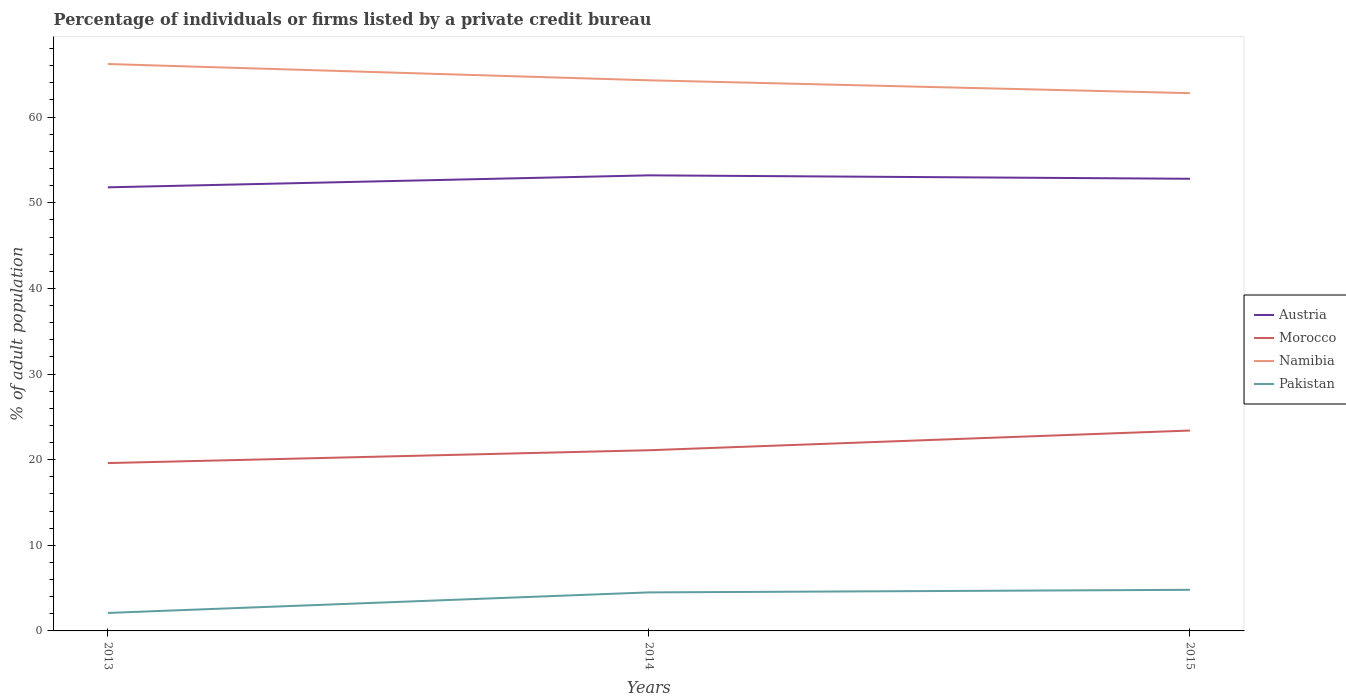How many different coloured lines are there?
Your answer should be very brief. 4. Does the line corresponding to Morocco intersect with the line corresponding to Austria?
Provide a short and direct response. No. Is the number of lines equal to the number of legend labels?
Offer a very short reply. Yes. Across all years, what is the maximum percentage of population listed by a private credit bureau in Namibia?
Offer a terse response. 62.8. In which year was the percentage of population listed by a private credit bureau in Namibia maximum?
Provide a short and direct response. 2015. What is the total percentage of population listed by a private credit bureau in Austria in the graph?
Give a very brief answer. -1.4. What is the difference between the highest and the second highest percentage of population listed by a private credit bureau in Austria?
Provide a succinct answer. 1.4. What is the difference between the highest and the lowest percentage of population listed by a private credit bureau in Austria?
Give a very brief answer. 2. How many years are there in the graph?
Provide a short and direct response. 3. Are the values on the major ticks of Y-axis written in scientific E-notation?
Give a very brief answer. No. Does the graph contain grids?
Your answer should be compact. No. Where does the legend appear in the graph?
Provide a succinct answer. Center right. How many legend labels are there?
Keep it short and to the point. 4. What is the title of the graph?
Ensure brevity in your answer.  Percentage of individuals or firms listed by a private credit bureau. Does "Timor-Leste" appear as one of the legend labels in the graph?
Your answer should be compact. No. What is the label or title of the X-axis?
Offer a very short reply. Years. What is the label or title of the Y-axis?
Your answer should be very brief. % of adult population. What is the % of adult population of Austria in 2013?
Your answer should be very brief. 51.8. What is the % of adult population in Morocco in 2013?
Ensure brevity in your answer.  19.6. What is the % of adult population of Namibia in 2013?
Your answer should be compact. 66.2. What is the % of adult population of Austria in 2014?
Make the answer very short. 53.2. What is the % of adult population of Morocco in 2014?
Your answer should be very brief. 21.1. What is the % of adult population in Namibia in 2014?
Offer a terse response. 64.3. What is the % of adult population in Austria in 2015?
Ensure brevity in your answer.  52.8. What is the % of adult population in Morocco in 2015?
Offer a very short reply. 23.4. What is the % of adult population in Namibia in 2015?
Offer a very short reply. 62.8. What is the % of adult population of Pakistan in 2015?
Ensure brevity in your answer.  4.8. Across all years, what is the maximum % of adult population of Austria?
Ensure brevity in your answer.  53.2. Across all years, what is the maximum % of adult population of Morocco?
Your answer should be very brief. 23.4. Across all years, what is the maximum % of adult population in Namibia?
Provide a succinct answer. 66.2. Across all years, what is the minimum % of adult population of Austria?
Your response must be concise. 51.8. Across all years, what is the minimum % of adult population of Morocco?
Give a very brief answer. 19.6. Across all years, what is the minimum % of adult population of Namibia?
Offer a very short reply. 62.8. What is the total % of adult population of Austria in the graph?
Your answer should be very brief. 157.8. What is the total % of adult population in Morocco in the graph?
Your answer should be very brief. 64.1. What is the total % of adult population in Namibia in the graph?
Your response must be concise. 193.3. What is the total % of adult population of Pakistan in the graph?
Ensure brevity in your answer.  11.4. What is the difference between the % of adult population of Austria in 2013 and that in 2014?
Offer a terse response. -1.4. What is the difference between the % of adult population of Morocco in 2013 and that in 2014?
Make the answer very short. -1.5. What is the difference between the % of adult population in Namibia in 2013 and that in 2014?
Ensure brevity in your answer.  1.9. What is the difference between the % of adult population of Pakistan in 2013 and that in 2015?
Your answer should be very brief. -2.7. What is the difference between the % of adult population of Austria in 2014 and that in 2015?
Offer a very short reply. 0.4. What is the difference between the % of adult population of Namibia in 2014 and that in 2015?
Your answer should be compact. 1.5. What is the difference between the % of adult population of Pakistan in 2014 and that in 2015?
Provide a short and direct response. -0.3. What is the difference between the % of adult population of Austria in 2013 and the % of adult population of Morocco in 2014?
Offer a very short reply. 30.7. What is the difference between the % of adult population in Austria in 2013 and the % of adult population in Pakistan in 2014?
Ensure brevity in your answer.  47.3. What is the difference between the % of adult population of Morocco in 2013 and the % of adult population of Namibia in 2014?
Offer a terse response. -44.7. What is the difference between the % of adult population of Morocco in 2013 and the % of adult population of Pakistan in 2014?
Offer a very short reply. 15.1. What is the difference between the % of adult population in Namibia in 2013 and the % of adult population in Pakistan in 2014?
Your answer should be compact. 61.7. What is the difference between the % of adult population in Austria in 2013 and the % of adult population in Morocco in 2015?
Provide a succinct answer. 28.4. What is the difference between the % of adult population of Austria in 2013 and the % of adult population of Namibia in 2015?
Make the answer very short. -11. What is the difference between the % of adult population of Austria in 2013 and the % of adult population of Pakistan in 2015?
Your response must be concise. 47. What is the difference between the % of adult population in Morocco in 2013 and the % of adult population in Namibia in 2015?
Make the answer very short. -43.2. What is the difference between the % of adult population of Namibia in 2013 and the % of adult population of Pakistan in 2015?
Provide a succinct answer. 61.4. What is the difference between the % of adult population of Austria in 2014 and the % of adult population of Morocco in 2015?
Give a very brief answer. 29.8. What is the difference between the % of adult population of Austria in 2014 and the % of adult population of Namibia in 2015?
Provide a short and direct response. -9.6. What is the difference between the % of adult population in Austria in 2014 and the % of adult population in Pakistan in 2015?
Your response must be concise. 48.4. What is the difference between the % of adult population of Morocco in 2014 and the % of adult population of Namibia in 2015?
Give a very brief answer. -41.7. What is the difference between the % of adult population in Morocco in 2014 and the % of adult population in Pakistan in 2015?
Ensure brevity in your answer.  16.3. What is the difference between the % of adult population of Namibia in 2014 and the % of adult population of Pakistan in 2015?
Your answer should be very brief. 59.5. What is the average % of adult population in Austria per year?
Offer a very short reply. 52.6. What is the average % of adult population in Morocco per year?
Your response must be concise. 21.37. What is the average % of adult population of Namibia per year?
Give a very brief answer. 64.43. In the year 2013, what is the difference between the % of adult population of Austria and % of adult population of Morocco?
Offer a terse response. 32.2. In the year 2013, what is the difference between the % of adult population in Austria and % of adult population in Namibia?
Your answer should be compact. -14.4. In the year 2013, what is the difference between the % of adult population in Austria and % of adult population in Pakistan?
Your answer should be compact. 49.7. In the year 2013, what is the difference between the % of adult population in Morocco and % of adult population in Namibia?
Your answer should be very brief. -46.6. In the year 2013, what is the difference between the % of adult population in Namibia and % of adult population in Pakistan?
Provide a succinct answer. 64.1. In the year 2014, what is the difference between the % of adult population of Austria and % of adult population of Morocco?
Give a very brief answer. 32.1. In the year 2014, what is the difference between the % of adult population of Austria and % of adult population of Namibia?
Offer a very short reply. -11.1. In the year 2014, what is the difference between the % of adult population of Austria and % of adult population of Pakistan?
Keep it short and to the point. 48.7. In the year 2014, what is the difference between the % of adult population of Morocco and % of adult population of Namibia?
Offer a terse response. -43.2. In the year 2014, what is the difference between the % of adult population of Namibia and % of adult population of Pakistan?
Offer a very short reply. 59.8. In the year 2015, what is the difference between the % of adult population of Austria and % of adult population of Morocco?
Your answer should be very brief. 29.4. In the year 2015, what is the difference between the % of adult population of Morocco and % of adult population of Namibia?
Your response must be concise. -39.4. What is the ratio of the % of adult population of Austria in 2013 to that in 2014?
Offer a very short reply. 0.97. What is the ratio of the % of adult population of Morocco in 2013 to that in 2014?
Make the answer very short. 0.93. What is the ratio of the % of adult population in Namibia in 2013 to that in 2014?
Offer a very short reply. 1.03. What is the ratio of the % of adult population of Pakistan in 2013 to that in 2014?
Provide a succinct answer. 0.47. What is the ratio of the % of adult population in Austria in 2013 to that in 2015?
Keep it short and to the point. 0.98. What is the ratio of the % of adult population of Morocco in 2013 to that in 2015?
Your response must be concise. 0.84. What is the ratio of the % of adult population in Namibia in 2013 to that in 2015?
Your response must be concise. 1.05. What is the ratio of the % of adult population in Pakistan in 2013 to that in 2015?
Keep it short and to the point. 0.44. What is the ratio of the % of adult population in Austria in 2014 to that in 2015?
Offer a very short reply. 1.01. What is the ratio of the % of adult population of Morocco in 2014 to that in 2015?
Ensure brevity in your answer.  0.9. What is the ratio of the % of adult population in Namibia in 2014 to that in 2015?
Make the answer very short. 1.02. What is the ratio of the % of adult population of Pakistan in 2014 to that in 2015?
Your response must be concise. 0.94. What is the difference between the highest and the second highest % of adult population of Austria?
Your response must be concise. 0.4. What is the difference between the highest and the second highest % of adult population in Namibia?
Provide a short and direct response. 1.9. What is the difference between the highest and the second highest % of adult population of Pakistan?
Make the answer very short. 0.3. What is the difference between the highest and the lowest % of adult population in Austria?
Your response must be concise. 1.4. What is the difference between the highest and the lowest % of adult population of Morocco?
Provide a short and direct response. 3.8. What is the difference between the highest and the lowest % of adult population of Pakistan?
Offer a very short reply. 2.7. 